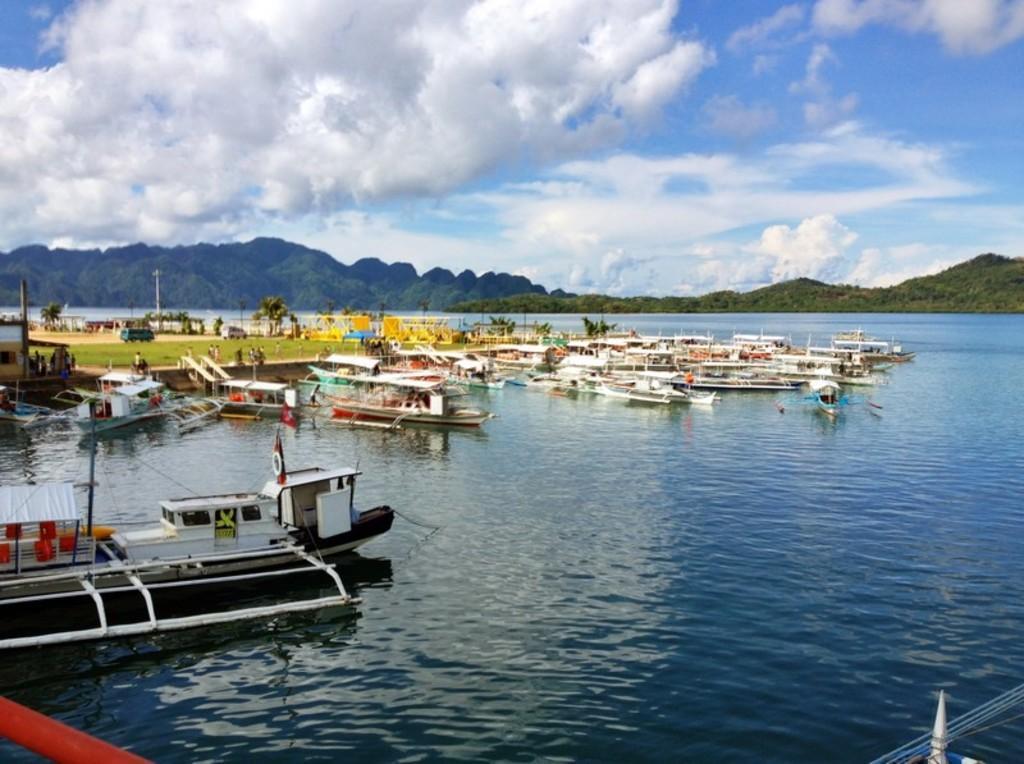In one or two sentences, can you explain what this image depicts? In this image there are a few boats on the water, beside the boats on the surface there are a few people walking and there is a car and some other objects. On the surface there are trees, lamp posts and a building. In the background of the image there are mountains. At the top of the image there are clouds in the sky. 